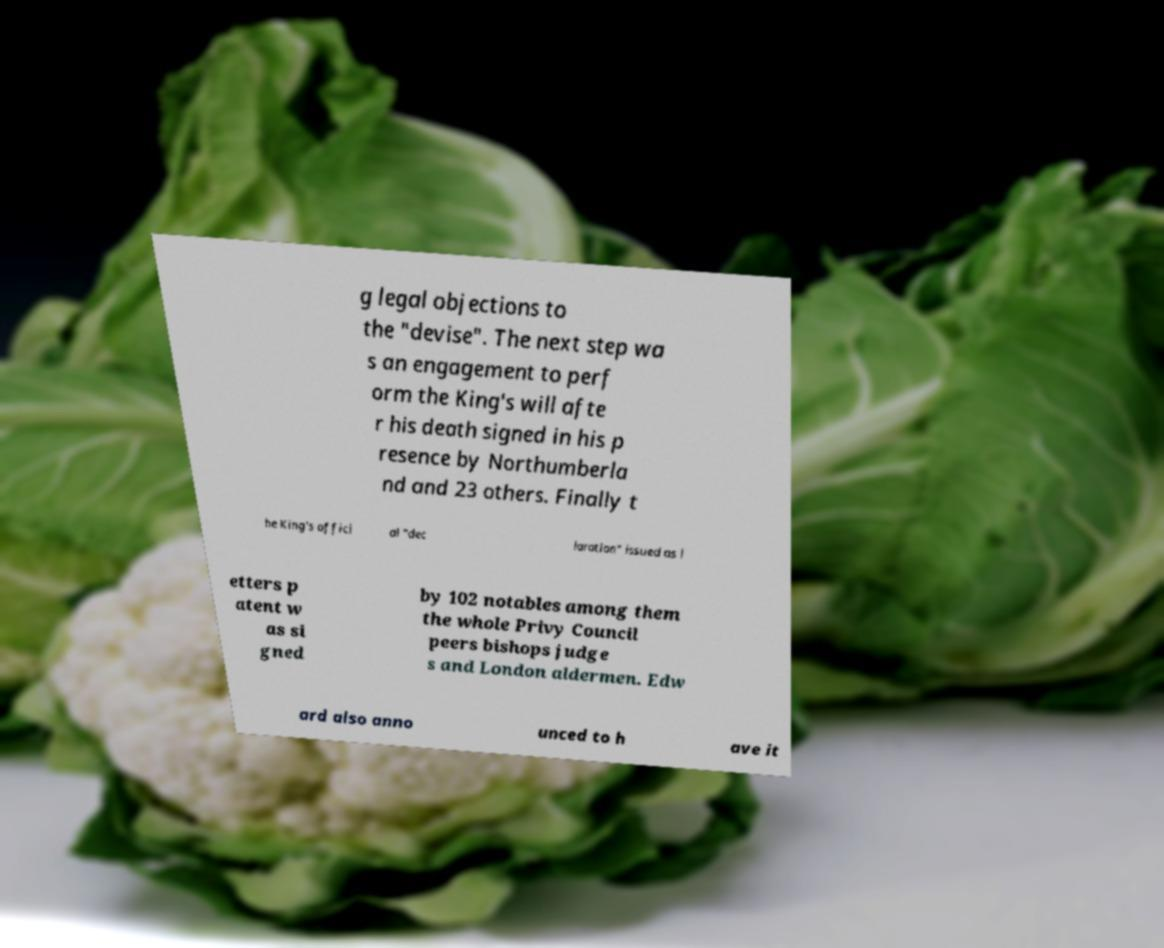Please identify and transcribe the text found in this image. g legal objections to the "devise". The next step wa s an engagement to perf orm the King's will afte r his death signed in his p resence by Northumberla nd and 23 others. Finally t he King's offici al "dec laration" issued as l etters p atent w as si gned by 102 notables among them the whole Privy Council peers bishops judge s and London aldermen. Edw ard also anno unced to h ave it 